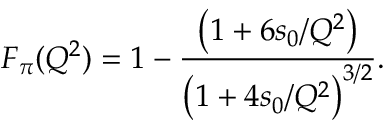<formula> <loc_0><loc_0><loc_500><loc_500>F _ { \pi } ( Q ^ { 2 } ) = 1 - { \frac { \left ( 1 + 6 s _ { 0 } / Q ^ { 2 } \right ) } { \left ( 1 + 4 s _ { 0 } / Q ^ { 2 } \right ) ^ { 3 / 2 } } } .</formula> 